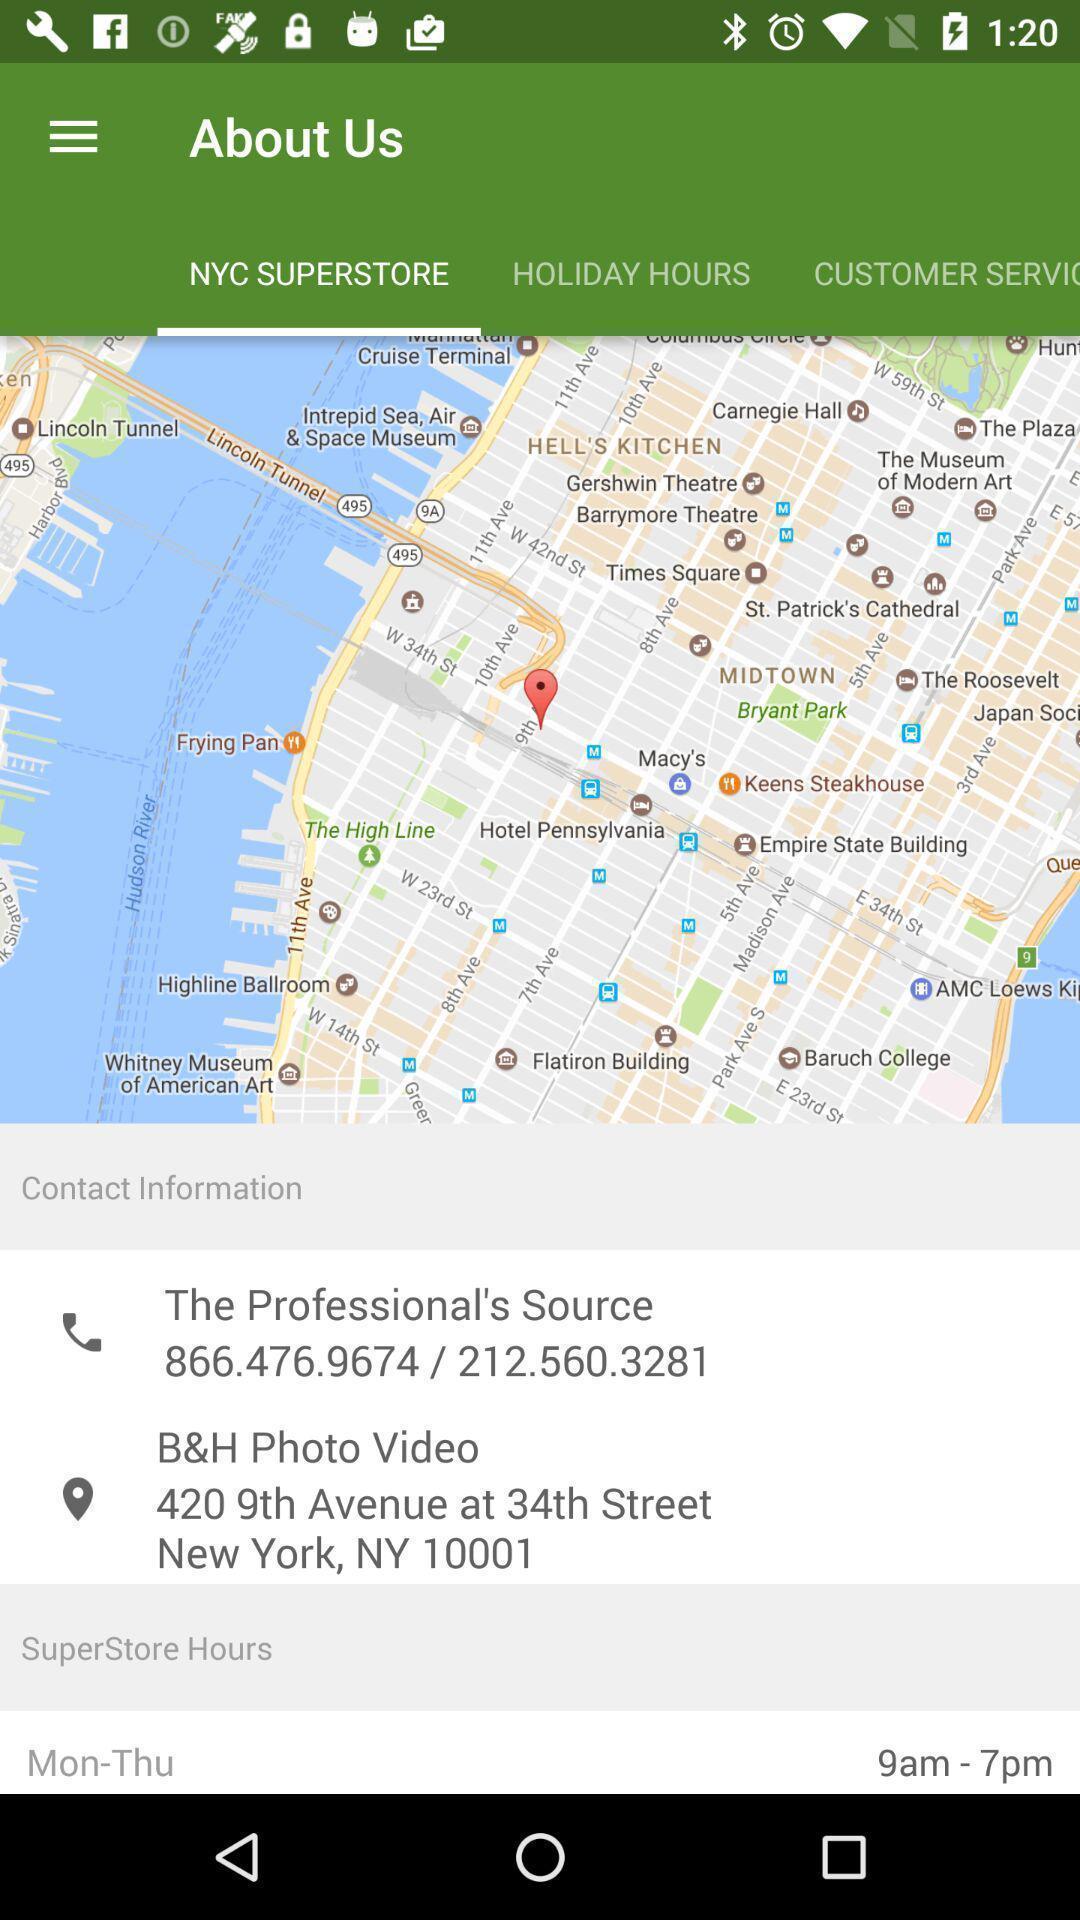Describe the visual elements of this screenshot. Screen displaying the location and its contact information. 